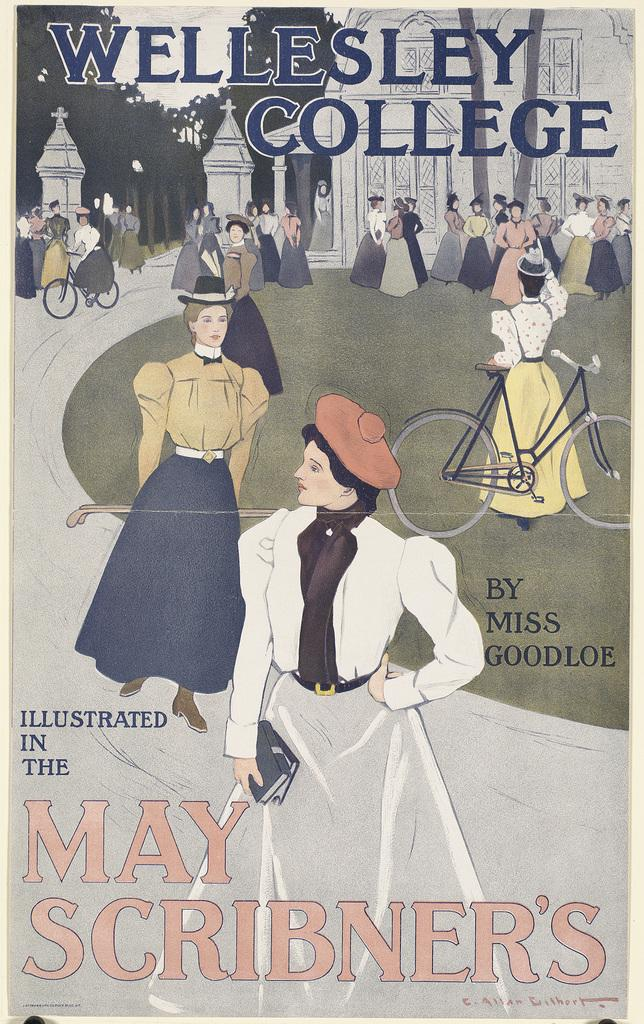<image>
Create a compact narrative representing the image presented. A copy of a book written by Miss Goodloe and illustrated in May Scribner's. 